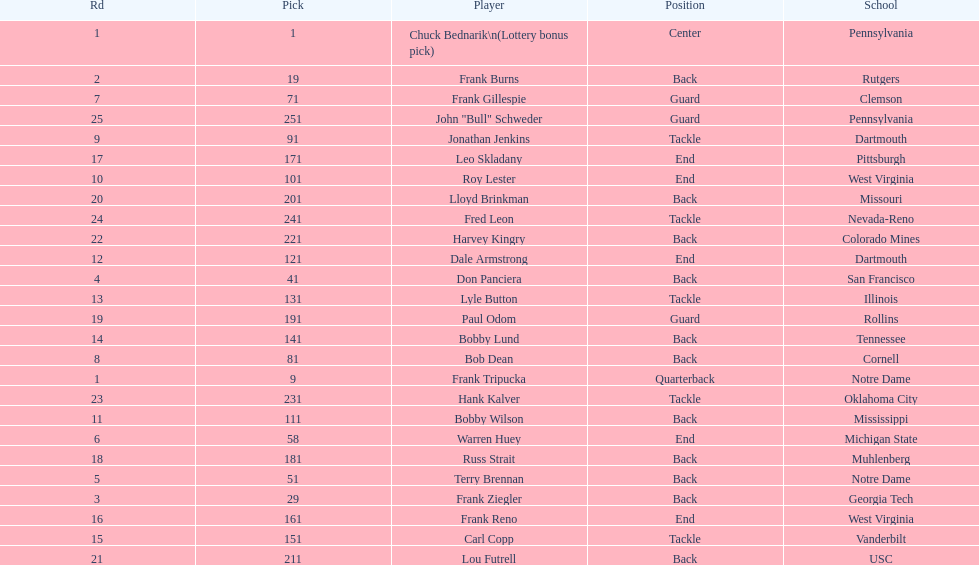Highest rd number? 25. 